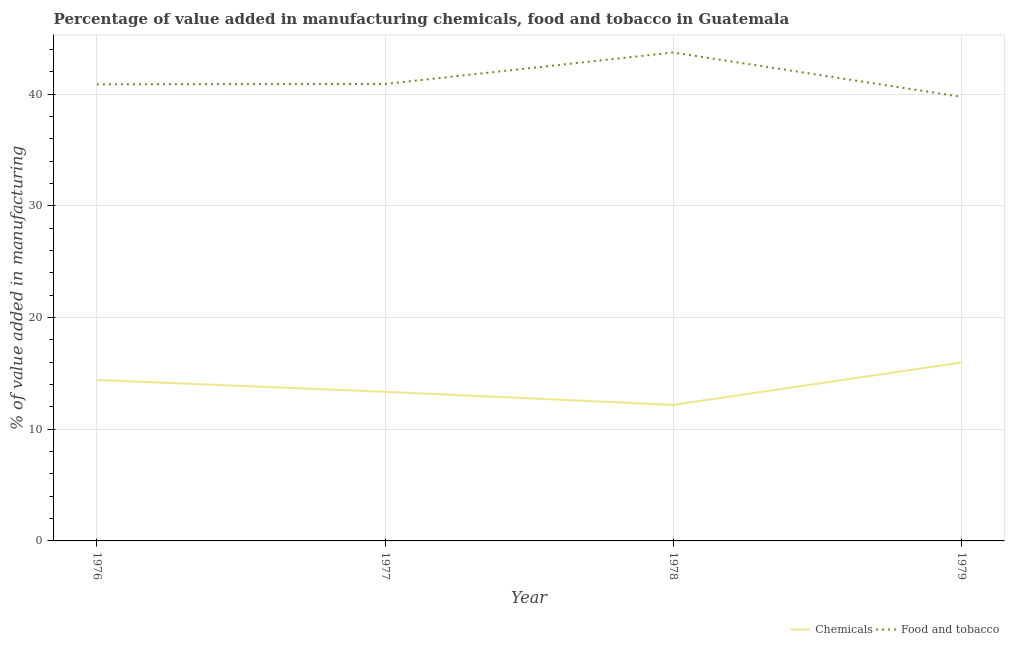How many different coloured lines are there?
Your answer should be very brief. 2. Does the line corresponding to value added by manufacturing food and tobacco intersect with the line corresponding to value added by  manufacturing chemicals?
Your answer should be compact. No. Is the number of lines equal to the number of legend labels?
Provide a succinct answer. Yes. What is the value added by  manufacturing chemicals in 1978?
Your answer should be compact. 12.18. Across all years, what is the maximum value added by  manufacturing chemicals?
Ensure brevity in your answer.  15.98. Across all years, what is the minimum value added by  manufacturing chemicals?
Offer a very short reply. 12.18. In which year was the value added by manufacturing food and tobacco maximum?
Your response must be concise. 1978. In which year was the value added by manufacturing food and tobacco minimum?
Offer a very short reply. 1979. What is the total value added by manufacturing food and tobacco in the graph?
Make the answer very short. 165.32. What is the difference between the value added by manufacturing food and tobacco in 1977 and that in 1978?
Offer a very short reply. -2.82. What is the difference between the value added by manufacturing food and tobacco in 1976 and the value added by  manufacturing chemicals in 1979?
Provide a succinct answer. 24.91. What is the average value added by manufacturing food and tobacco per year?
Provide a succinct answer. 41.33. In the year 1979, what is the difference between the value added by  manufacturing chemicals and value added by manufacturing food and tobacco?
Offer a very short reply. -23.79. What is the ratio of the value added by  manufacturing chemicals in 1977 to that in 1979?
Your response must be concise. 0.84. Is the value added by  manufacturing chemicals in 1976 less than that in 1978?
Provide a short and direct response. No. Is the difference between the value added by  manufacturing chemicals in 1976 and 1978 greater than the difference between the value added by manufacturing food and tobacco in 1976 and 1978?
Your answer should be compact. Yes. What is the difference between the highest and the second highest value added by  manufacturing chemicals?
Offer a terse response. 1.57. What is the difference between the highest and the lowest value added by manufacturing food and tobacco?
Your answer should be very brief. 3.97. In how many years, is the value added by manufacturing food and tobacco greater than the average value added by manufacturing food and tobacco taken over all years?
Offer a very short reply. 1. Is the sum of the value added by  manufacturing chemicals in 1977 and 1978 greater than the maximum value added by manufacturing food and tobacco across all years?
Provide a succinct answer. No. Does the value added by  manufacturing chemicals monotonically increase over the years?
Keep it short and to the point. No. Is the value added by manufacturing food and tobacco strictly greater than the value added by  manufacturing chemicals over the years?
Ensure brevity in your answer.  Yes. How are the legend labels stacked?
Provide a short and direct response. Horizontal. What is the title of the graph?
Provide a short and direct response. Percentage of value added in manufacturing chemicals, food and tobacco in Guatemala. What is the label or title of the X-axis?
Your response must be concise. Year. What is the label or title of the Y-axis?
Keep it short and to the point. % of value added in manufacturing. What is the % of value added in manufacturing in Chemicals in 1976?
Offer a terse response. 14.41. What is the % of value added in manufacturing in Food and tobacco in 1976?
Your answer should be very brief. 40.89. What is the % of value added in manufacturing in Chemicals in 1977?
Your response must be concise. 13.36. What is the % of value added in manufacturing of Food and tobacco in 1977?
Make the answer very short. 40.92. What is the % of value added in manufacturing of Chemicals in 1978?
Make the answer very short. 12.18. What is the % of value added in manufacturing of Food and tobacco in 1978?
Give a very brief answer. 43.74. What is the % of value added in manufacturing in Chemicals in 1979?
Give a very brief answer. 15.98. What is the % of value added in manufacturing of Food and tobacco in 1979?
Your response must be concise. 39.77. Across all years, what is the maximum % of value added in manufacturing in Chemicals?
Provide a short and direct response. 15.98. Across all years, what is the maximum % of value added in manufacturing of Food and tobacco?
Offer a very short reply. 43.74. Across all years, what is the minimum % of value added in manufacturing of Chemicals?
Make the answer very short. 12.18. Across all years, what is the minimum % of value added in manufacturing in Food and tobacco?
Your answer should be compact. 39.77. What is the total % of value added in manufacturing in Chemicals in the graph?
Your response must be concise. 55.92. What is the total % of value added in manufacturing of Food and tobacco in the graph?
Provide a short and direct response. 165.32. What is the difference between the % of value added in manufacturing in Chemicals in 1976 and that in 1977?
Your answer should be very brief. 1.05. What is the difference between the % of value added in manufacturing of Food and tobacco in 1976 and that in 1977?
Keep it short and to the point. -0.03. What is the difference between the % of value added in manufacturing of Chemicals in 1976 and that in 1978?
Keep it short and to the point. 2.23. What is the difference between the % of value added in manufacturing in Food and tobacco in 1976 and that in 1978?
Keep it short and to the point. -2.85. What is the difference between the % of value added in manufacturing in Chemicals in 1976 and that in 1979?
Offer a very short reply. -1.57. What is the difference between the % of value added in manufacturing of Food and tobacco in 1976 and that in 1979?
Provide a succinct answer. 1.12. What is the difference between the % of value added in manufacturing of Chemicals in 1977 and that in 1978?
Keep it short and to the point. 1.17. What is the difference between the % of value added in manufacturing in Food and tobacco in 1977 and that in 1978?
Provide a short and direct response. -2.82. What is the difference between the % of value added in manufacturing in Chemicals in 1977 and that in 1979?
Your response must be concise. -2.62. What is the difference between the % of value added in manufacturing in Food and tobacco in 1977 and that in 1979?
Ensure brevity in your answer.  1.15. What is the difference between the % of value added in manufacturing of Chemicals in 1978 and that in 1979?
Your response must be concise. -3.79. What is the difference between the % of value added in manufacturing in Food and tobacco in 1978 and that in 1979?
Your answer should be compact. 3.97. What is the difference between the % of value added in manufacturing in Chemicals in 1976 and the % of value added in manufacturing in Food and tobacco in 1977?
Your answer should be compact. -26.51. What is the difference between the % of value added in manufacturing in Chemicals in 1976 and the % of value added in manufacturing in Food and tobacco in 1978?
Ensure brevity in your answer.  -29.33. What is the difference between the % of value added in manufacturing in Chemicals in 1976 and the % of value added in manufacturing in Food and tobacco in 1979?
Your answer should be very brief. -25.36. What is the difference between the % of value added in manufacturing in Chemicals in 1977 and the % of value added in manufacturing in Food and tobacco in 1978?
Make the answer very short. -30.38. What is the difference between the % of value added in manufacturing of Chemicals in 1977 and the % of value added in manufacturing of Food and tobacco in 1979?
Your answer should be compact. -26.42. What is the difference between the % of value added in manufacturing of Chemicals in 1978 and the % of value added in manufacturing of Food and tobacco in 1979?
Make the answer very short. -27.59. What is the average % of value added in manufacturing of Chemicals per year?
Your answer should be compact. 13.98. What is the average % of value added in manufacturing of Food and tobacco per year?
Make the answer very short. 41.33. In the year 1976, what is the difference between the % of value added in manufacturing of Chemicals and % of value added in manufacturing of Food and tobacco?
Provide a succinct answer. -26.48. In the year 1977, what is the difference between the % of value added in manufacturing in Chemicals and % of value added in manufacturing in Food and tobacco?
Your response must be concise. -27.57. In the year 1978, what is the difference between the % of value added in manufacturing of Chemicals and % of value added in manufacturing of Food and tobacco?
Offer a terse response. -31.56. In the year 1979, what is the difference between the % of value added in manufacturing of Chemicals and % of value added in manufacturing of Food and tobacco?
Your answer should be very brief. -23.79. What is the ratio of the % of value added in manufacturing in Chemicals in 1976 to that in 1977?
Ensure brevity in your answer.  1.08. What is the ratio of the % of value added in manufacturing in Food and tobacco in 1976 to that in 1977?
Offer a terse response. 1. What is the ratio of the % of value added in manufacturing in Chemicals in 1976 to that in 1978?
Keep it short and to the point. 1.18. What is the ratio of the % of value added in manufacturing in Food and tobacco in 1976 to that in 1978?
Keep it short and to the point. 0.93. What is the ratio of the % of value added in manufacturing of Chemicals in 1976 to that in 1979?
Your answer should be very brief. 0.9. What is the ratio of the % of value added in manufacturing of Food and tobacco in 1976 to that in 1979?
Your answer should be compact. 1.03. What is the ratio of the % of value added in manufacturing in Chemicals in 1977 to that in 1978?
Ensure brevity in your answer.  1.1. What is the ratio of the % of value added in manufacturing of Food and tobacco in 1977 to that in 1978?
Offer a terse response. 0.94. What is the ratio of the % of value added in manufacturing of Chemicals in 1977 to that in 1979?
Give a very brief answer. 0.84. What is the ratio of the % of value added in manufacturing in Food and tobacco in 1977 to that in 1979?
Your answer should be compact. 1.03. What is the ratio of the % of value added in manufacturing of Chemicals in 1978 to that in 1979?
Provide a succinct answer. 0.76. What is the ratio of the % of value added in manufacturing of Food and tobacco in 1978 to that in 1979?
Provide a short and direct response. 1.1. What is the difference between the highest and the second highest % of value added in manufacturing of Chemicals?
Keep it short and to the point. 1.57. What is the difference between the highest and the second highest % of value added in manufacturing in Food and tobacco?
Make the answer very short. 2.82. What is the difference between the highest and the lowest % of value added in manufacturing in Chemicals?
Provide a succinct answer. 3.79. What is the difference between the highest and the lowest % of value added in manufacturing of Food and tobacco?
Provide a short and direct response. 3.97. 